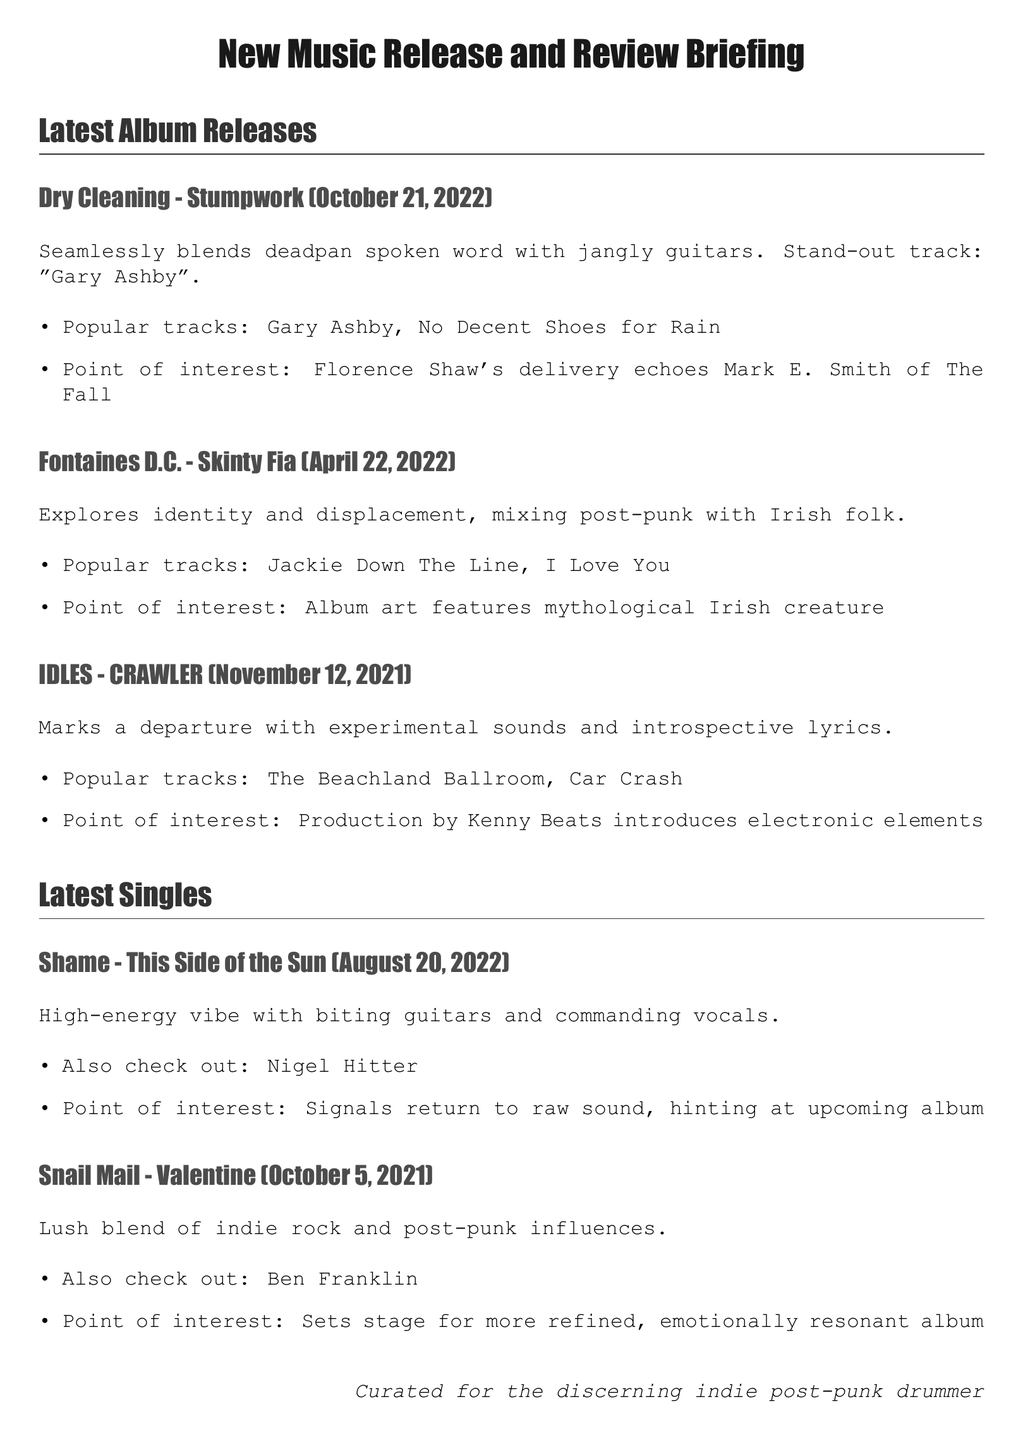What is the title of Dry Cleaning's latest album? The document states that Dry Cleaning's latest album is titled "Stumpwork."
Answer: Stumpwork When was "Skinty Fia" by Fontaines D.C. released? The document indicates that "Skinty Fia" was released on April 22, 2022.
Answer: April 22, 2022 What is a popular track from IDLES' album "CRAWLER"? One of the popular tracks listed for IDLES' album "CRAWLER" is "The Beachland Ballroom."
Answer: The Beachland Ballroom Which band released the single "This Side of the Sun"? The document specifies that the single "This Side of the Sun" was released by Shame.
Answer: Shame What production element is noted in IDLES' album "CRAWLER"? The document highlights that the production of "CRAWLER" by Kenny Beats introduces electronic elements.
Answer: Electronic elements What point of interest is mentioned about Dry Cleaning's delivery? The document notes that Florence Shaw's delivery echoes Mark E. Smith of The Fall.
Answer: Echoes Mark E. Smith What genre does Snail Mail's "Valentine" blend? The document states that "Valentine" features a blend of indie rock and post-punk influences.
Answer: Indie rock and post-punk Which track by Shame signals a return to a raw sound? The document mentions that "This Side of the Sun" signals a return to a raw sound for Shame.
Answer: This Side of the Sun What is the focus of Fontaines D.C.'s "Skinty Fia"? The document states that "Skinty Fia" explores identity and displacement.
Answer: Identity and displacement 